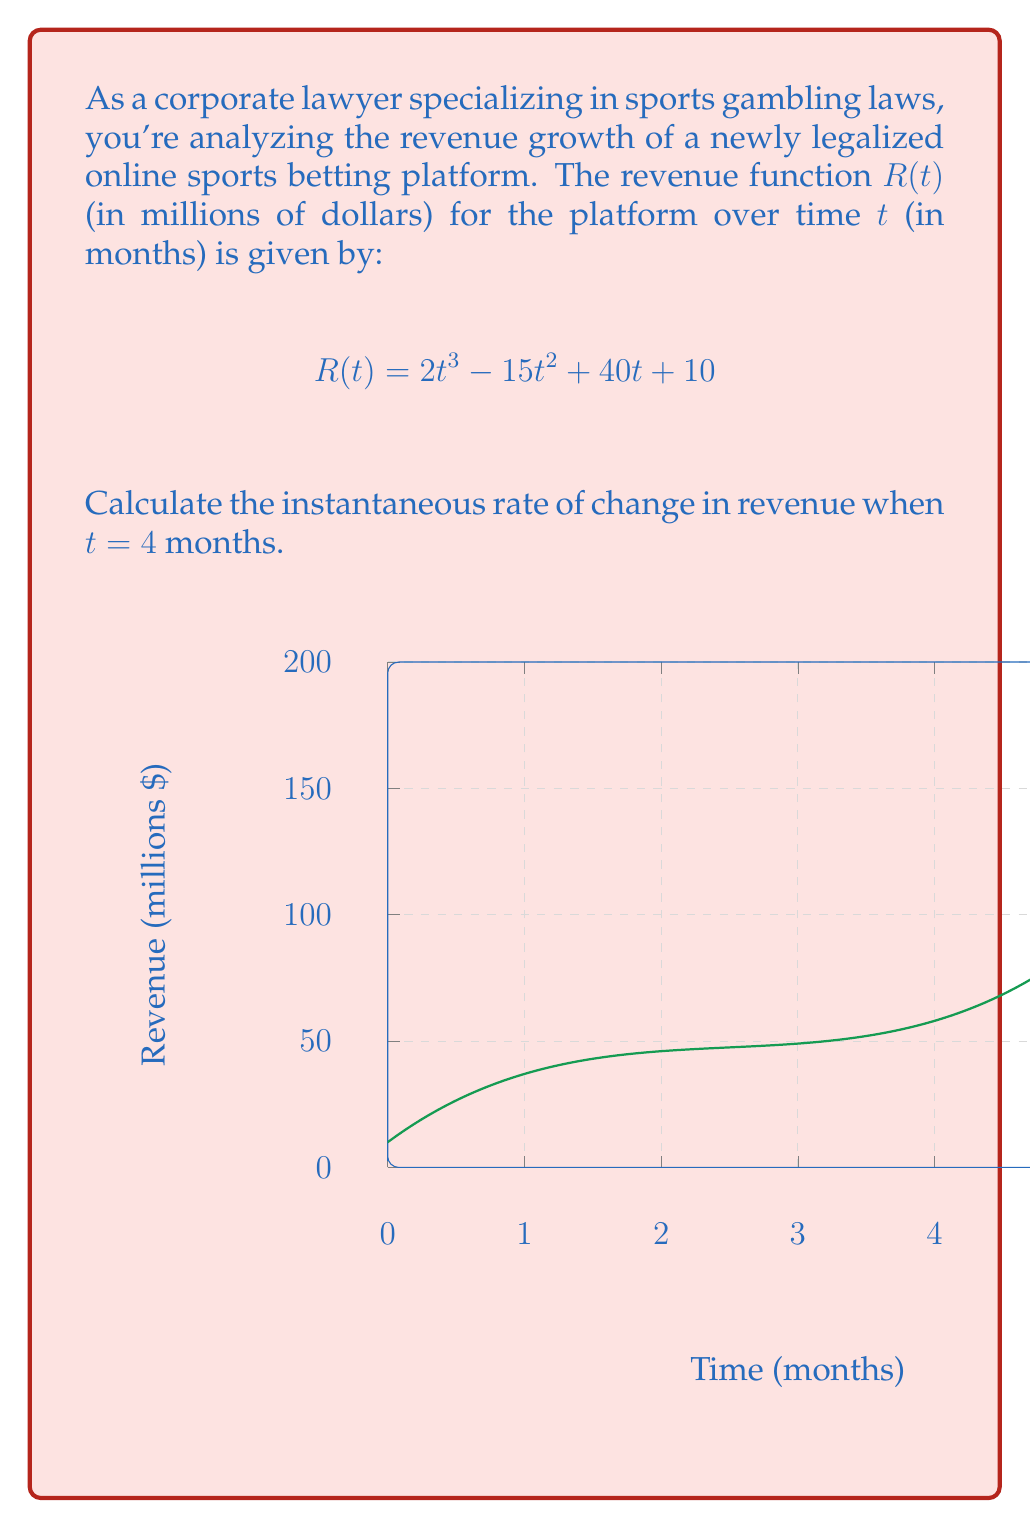Give your solution to this math problem. To find the instantaneous rate of change at $t = 4$, we need to calculate the derivative of the revenue function $R(t)$ and then evaluate it at $t = 4$.

Step 1: Find the derivative of $R(t)$
$$R(t) = 2t^3 - 15t^2 + 40t + 10$$
$$R'(t) = 6t^2 - 30t + 40$$

Step 2: Evaluate $R'(t)$ at $t = 4$
$$R'(4) = 6(4)^2 - 30(4) + 40$$
$$R'(4) = 6(16) - 120 + 40$$
$$R'(4) = 96 - 120 + 40$$
$$R'(4) = 16$$

The instantaneous rate of change at $t = 4$ months is 16 million dollars per month.
Answer: $16$ million dollars per month 